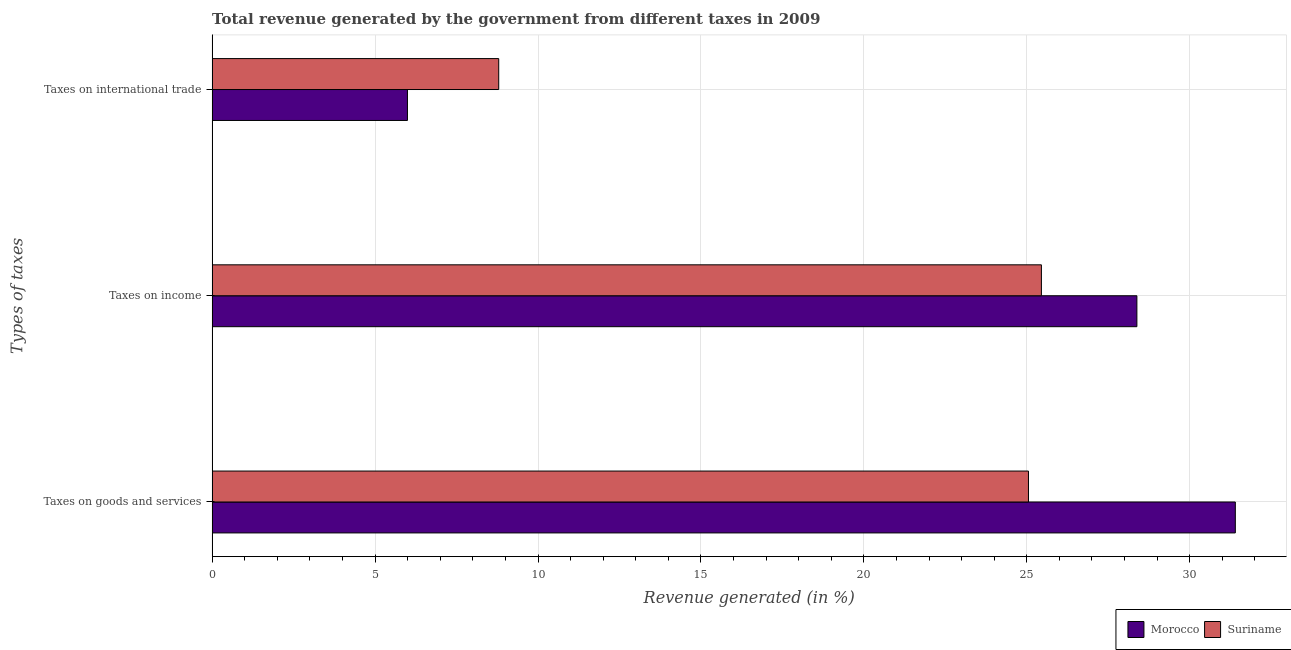How many different coloured bars are there?
Keep it short and to the point. 2. Are the number of bars per tick equal to the number of legend labels?
Offer a terse response. Yes. How many bars are there on the 1st tick from the top?
Provide a succinct answer. 2. How many bars are there on the 3rd tick from the bottom?
Your response must be concise. 2. What is the label of the 3rd group of bars from the top?
Your answer should be very brief. Taxes on goods and services. What is the percentage of revenue generated by taxes on goods and services in Morocco?
Ensure brevity in your answer.  31.4. Across all countries, what is the maximum percentage of revenue generated by taxes on goods and services?
Your answer should be compact. 31.4. Across all countries, what is the minimum percentage of revenue generated by taxes on goods and services?
Offer a terse response. 25.05. In which country was the percentage of revenue generated by taxes on goods and services maximum?
Your answer should be very brief. Morocco. In which country was the percentage of revenue generated by taxes on income minimum?
Your answer should be very brief. Suriname. What is the total percentage of revenue generated by tax on international trade in the graph?
Offer a terse response. 14.79. What is the difference between the percentage of revenue generated by tax on international trade in Suriname and that in Morocco?
Your answer should be very brief. 2.8. What is the difference between the percentage of revenue generated by tax on international trade in Suriname and the percentage of revenue generated by taxes on goods and services in Morocco?
Offer a very short reply. -22.6. What is the average percentage of revenue generated by taxes on income per country?
Offer a very short reply. 26.91. What is the difference between the percentage of revenue generated by taxes on goods and services and percentage of revenue generated by taxes on income in Suriname?
Ensure brevity in your answer.  -0.4. What is the ratio of the percentage of revenue generated by tax on international trade in Suriname to that in Morocco?
Give a very brief answer. 1.47. Is the percentage of revenue generated by taxes on goods and services in Suriname less than that in Morocco?
Your answer should be compact. Yes. Is the difference between the percentage of revenue generated by taxes on income in Morocco and Suriname greater than the difference between the percentage of revenue generated by tax on international trade in Morocco and Suriname?
Ensure brevity in your answer.  Yes. What is the difference between the highest and the second highest percentage of revenue generated by tax on international trade?
Give a very brief answer. 2.8. What is the difference between the highest and the lowest percentage of revenue generated by tax on international trade?
Offer a terse response. 2.8. In how many countries, is the percentage of revenue generated by taxes on income greater than the average percentage of revenue generated by taxes on income taken over all countries?
Your response must be concise. 1. What does the 1st bar from the top in Taxes on international trade represents?
Give a very brief answer. Suriname. What does the 1st bar from the bottom in Taxes on international trade represents?
Your answer should be very brief. Morocco. Are all the bars in the graph horizontal?
Ensure brevity in your answer.  Yes. How many countries are there in the graph?
Your response must be concise. 2. Are the values on the major ticks of X-axis written in scientific E-notation?
Offer a very short reply. No. Does the graph contain any zero values?
Offer a terse response. No. Does the graph contain grids?
Your answer should be very brief. Yes. Where does the legend appear in the graph?
Provide a short and direct response. Bottom right. How many legend labels are there?
Provide a short and direct response. 2. How are the legend labels stacked?
Offer a terse response. Horizontal. What is the title of the graph?
Make the answer very short. Total revenue generated by the government from different taxes in 2009. What is the label or title of the X-axis?
Make the answer very short. Revenue generated (in %). What is the label or title of the Y-axis?
Offer a very short reply. Types of taxes. What is the Revenue generated (in %) of Morocco in Taxes on goods and services?
Keep it short and to the point. 31.4. What is the Revenue generated (in %) in Suriname in Taxes on goods and services?
Ensure brevity in your answer.  25.05. What is the Revenue generated (in %) in Morocco in Taxes on income?
Ensure brevity in your answer.  28.38. What is the Revenue generated (in %) in Suriname in Taxes on income?
Your response must be concise. 25.45. What is the Revenue generated (in %) in Morocco in Taxes on international trade?
Your answer should be compact. 5.99. What is the Revenue generated (in %) in Suriname in Taxes on international trade?
Your response must be concise. 8.79. Across all Types of taxes, what is the maximum Revenue generated (in %) of Morocco?
Offer a terse response. 31.4. Across all Types of taxes, what is the maximum Revenue generated (in %) in Suriname?
Give a very brief answer. 25.45. Across all Types of taxes, what is the minimum Revenue generated (in %) of Morocco?
Your answer should be compact. 5.99. Across all Types of taxes, what is the minimum Revenue generated (in %) of Suriname?
Offer a terse response. 8.79. What is the total Revenue generated (in %) in Morocco in the graph?
Your answer should be compact. 65.77. What is the total Revenue generated (in %) in Suriname in the graph?
Offer a very short reply. 59.29. What is the difference between the Revenue generated (in %) of Morocco in Taxes on goods and services and that in Taxes on income?
Keep it short and to the point. 3.02. What is the difference between the Revenue generated (in %) of Suriname in Taxes on goods and services and that in Taxes on income?
Your answer should be compact. -0.4. What is the difference between the Revenue generated (in %) in Morocco in Taxes on goods and services and that in Taxes on international trade?
Provide a short and direct response. 25.41. What is the difference between the Revenue generated (in %) of Suriname in Taxes on goods and services and that in Taxes on international trade?
Your response must be concise. 16.26. What is the difference between the Revenue generated (in %) in Morocco in Taxes on income and that in Taxes on international trade?
Offer a terse response. 22.38. What is the difference between the Revenue generated (in %) of Suriname in Taxes on income and that in Taxes on international trade?
Give a very brief answer. 16.65. What is the difference between the Revenue generated (in %) in Morocco in Taxes on goods and services and the Revenue generated (in %) in Suriname in Taxes on income?
Your answer should be compact. 5.95. What is the difference between the Revenue generated (in %) in Morocco in Taxes on goods and services and the Revenue generated (in %) in Suriname in Taxes on international trade?
Offer a very short reply. 22.6. What is the difference between the Revenue generated (in %) of Morocco in Taxes on income and the Revenue generated (in %) of Suriname in Taxes on international trade?
Offer a very short reply. 19.58. What is the average Revenue generated (in %) of Morocco per Types of taxes?
Keep it short and to the point. 21.92. What is the average Revenue generated (in %) of Suriname per Types of taxes?
Ensure brevity in your answer.  19.76. What is the difference between the Revenue generated (in %) in Morocco and Revenue generated (in %) in Suriname in Taxes on goods and services?
Make the answer very short. 6.35. What is the difference between the Revenue generated (in %) in Morocco and Revenue generated (in %) in Suriname in Taxes on income?
Your answer should be compact. 2.93. What is the difference between the Revenue generated (in %) in Morocco and Revenue generated (in %) in Suriname in Taxes on international trade?
Provide a succinct answer. -2.8. What is the ratio of the Revenue generated (in %) in Morocco in Taxes on goods and services to that in Taxes on income?
Ensure brevity in your answer.  1.11. What is the ratio of the Revenue generated (in %) in Suriname in Taxes on goods and services to that in Taxes on income?
Your response must be concise. 0.98. What is the ratio of the Revenue generated (in %) in Morocco in Taxes on goods and services to that in Taxes on international trade?
Your answer should be compact. 5.24. What is the ratio of the Revenue generated (in %) in Suriname in Taxes on goods and services to that in Taxes on international trade?
Provide a succinct answer. 2.85. What is the ratio of the Revenue generated (in %) in Morocco in Taxes on income to that in Taxes on international trade?
Your answer should be very brief. 4.73. What is the ratio of the Revenue generated (in %) in Suriname in Taxes on income to that in Taxes on international trade?
Your answer should be compact. 2.89. What is the difference between the highest and the second highest Revenue generated (in %) in Morocco?
Give a very brief answer. 3.02. What is the difference between the highest and the second highest Revenue generated (in %) of Suriname?
Provide a short and direct response. 0.4. What is the difference between the highest and the lowest Revenue generated (in %) of Morocco?
Your answer should be compact. 25.41. What is the difference between the highest and the lowest Revenue generated (in %) of Suriname?
Offer a very short reply. 16.65. 